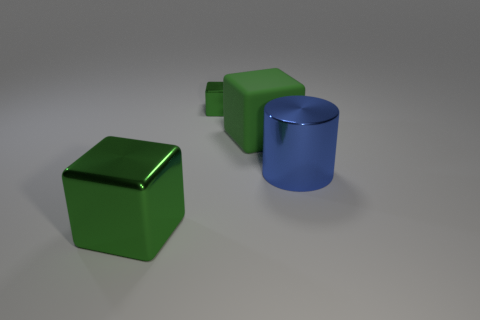How many green cubes must be subtracted to get 2 green cubes? 1 Subtract all tiny blocks. How many blocks are left? 2 Add 4 big green metal cubes. How many objects exist? 8 Subtract all blocks. How many objects are left? 1 Subtract 1 blocks. How many blocks are left? 2 Add 2 blue metallic cylinders. How many blue metallic cylinders are left? 3 Add 4 small cyan things. How many small cyan things exist? 4 Subtract 0 yellow balls. How many objects are left? 4 Subtract all red cylinders. Subtract all red blocks. How many cylinders are left? 1 Subtract all large blue metal objects. Subtract all green metallic objects. How many objects are left? 1 